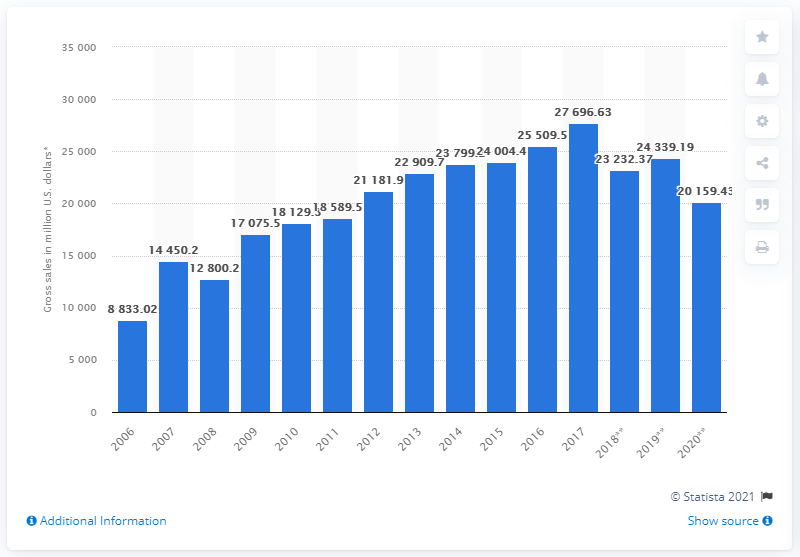Indicate a few pertinent items in this graphic. The H&M Group's global net sales for the fiscal year 2020 were SEK 20,159.43. 